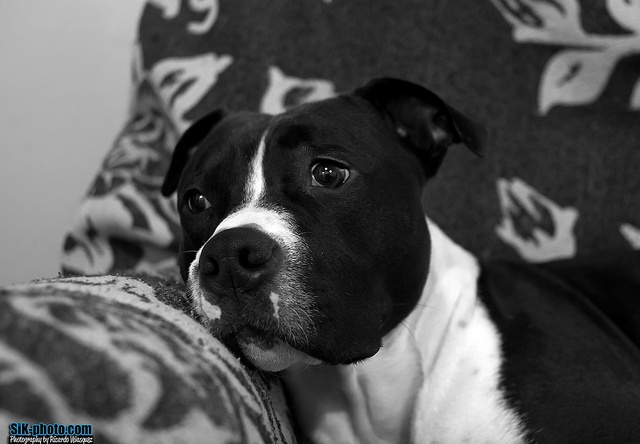Describe the objects in this image and their specific colors. I can see couch in darkgray, black, gray, and lightgray tones and dog in darkgray, black, lightgray, and gray tones in this image. 